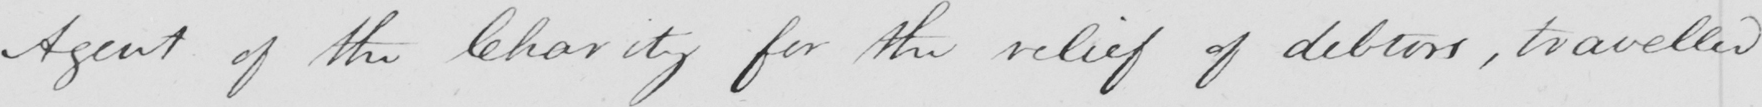What does this handwritten line say? Agent of the Charity for the relief of debtors , travelled 